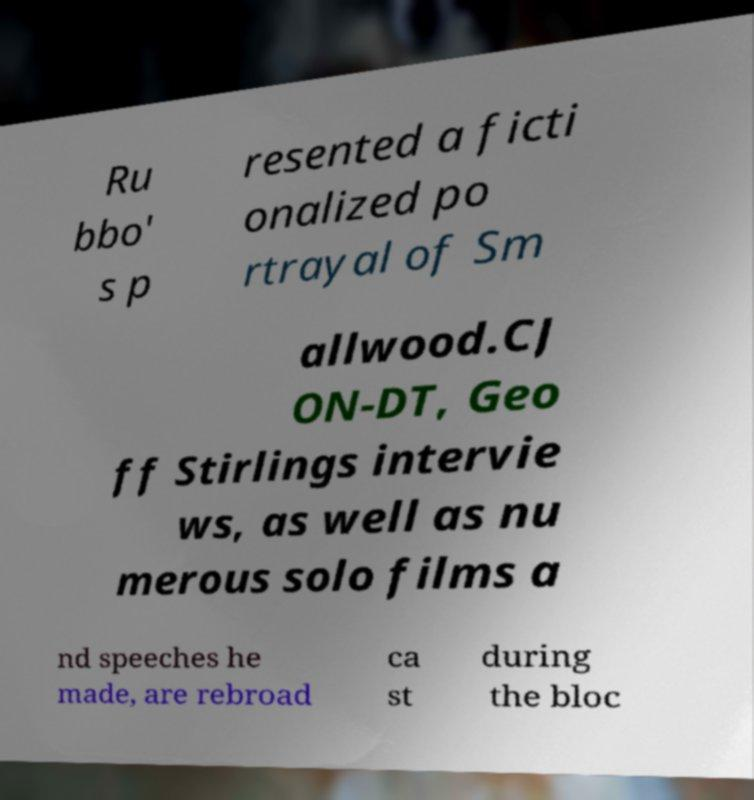Please read and relay the text visible in this image. What does it say? Ru bbo' s p resented a ficti onalized po rtrayal of Sm allwood.CJ ON-DT, Geo ff Stirlings intervie ws, as well as nu merous solo films a nd speeches he made, are rebroad ca st during the bloc 